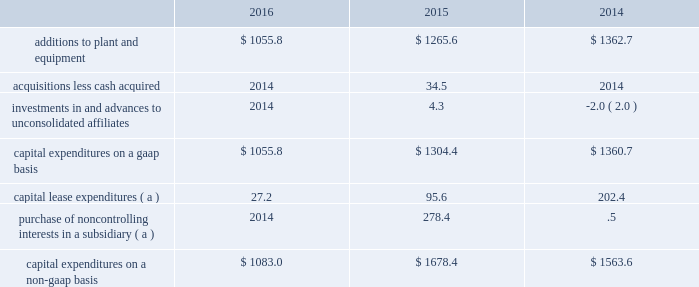Investing activities for the year ended 30 september 2016 , cash used for investing activities was $ 972.0 , driven by capital expenditures for plant and equipment of $ 1055.8 .
Proceeds from the sale of assets and investments of $ 85.5 was primarily driven by the receipt of $ 30.0 for our rights to a corporate aircraft that was under construction , $ 15.9 for the sale of our 20% ( 20 % ) equity investment in daido air products electronics , inc. , and $ 14.9 for the sale of a wholly owned subsidiary located in wuhu , china .
For the year ended 30 september 2015 , cash used for investing activities was $ 1250.5 , primarily capital expenditures for plant and equipment .
On 30 december 2014 , we acquired our partner 2019s equity ownership interest in a liquefied atmospheric industrial gases production joint venture in north america which increased our ownership from 50% ( 50 % ) to 100% ( 100 % ) .
Refer to note 6 , business combination , to the consolidated financial statements for additional information .
For the year ended 30 september 2014 , cash used for investing activities was $ 1316.5 , primarily capital expenditures for plant and equipment .
Refer to the capital expenditures section below for additional detail .
Capital expenditures capital expenditures are detailed in the table: .
( a ) we utilize a non-gaap measure in the computation of capital expenditures and include spending associated with facilities accounted for as capital leases and purchases of noncontrolling interests .
Certain contracts associated with facilities that are built to provide product to a specific customer are required to be accounted for as leases , and such spending is reflected as a use of cash within cash provided by operating activities , if the arrangement qualifies as a capital lease .
Additionally , the purchase of subsidiary shares from noncontrolling interests is accounted for as a financing activity in the statement of cash flows .
The presentation of this non-gaap measure is intended to enhance the usefulness of information by providing a measure that our management uses internally to evaluate and manage our expenditures .
Capital expenditures on a gaap basis in 2016 totaled $ 1055.8 , compared to $ 1265.6 in 2015 .
The decrease of $ 209.8 was primarily due to the completion of major projects in 2016 and 2015 .
Additions to plant and equipment also included support capital of a routine , ongoing nature , including expenditures for distribution equipment and facility improvements .
Spending in 2016 and 2015 included plant and equipment constructed to provide oxygen for coal gasification in china , hydrogen to the global market , oxygen to the steel industry , nitrogen to the electronic semiconductor industry , and capacity expansion for the materials technologies segment .
Capital expenditures on a non-gaap basis in 2016 totaled $ 1083.0 compared to $ 1678.4 in 2015 .
The decrease of $ 595.4 was primarily due to the prior year purchase of the 30.5% ( 30.5 % ) equity interest in our indura s.a .
Subsidiary from the largest minority shareholder for $ 277.9 .
Refer to note 21 , noncontrolling interests , to the consolidated financial statements for additional details .
Additionally , capital lease expenditures of $ 27.2 , decreased by $ 68.4 , reflecting lower project spending .
On 19 april 2015 , a joint venture between air products and acwa holding entered into a 20-year oxygen and nitrogen supply agreement to supply saudi aramco 2019s oil refinery and power plant being built in jazan , saudi arabia .
Air products owns 25% ( 25 % ) of the joint venture .
During 2016 and 2015 , we recorded noncash transactions which resulted in an increase of $ 26.9 and $ 67.5 , respectively , to our investment in net assets of and advances to equity affiliates for our obligation to invest in the joint venture .
These noncash transactions have been excluded from the consolidated statements of cash flows .
In total , we expect to invest approximately $ 100 in this joint venture .
Air products has also entered into a sale of equipment contract with the joint venture to engineer , procure , and construct the industrial gas facilities that will supply the gases to saudi aramco. .
Considering the 2015's capital expenditures on a gaap basis , what is the percentage of the investments in and advances to unconsolidated affiliates in the total value? 
Rationale: it is the investments in and advances to unconsolidated affiliates value divided by the total and turned into a percentage .
Computations: (4.3 / 1304.4)
Answer: 0.0033. 